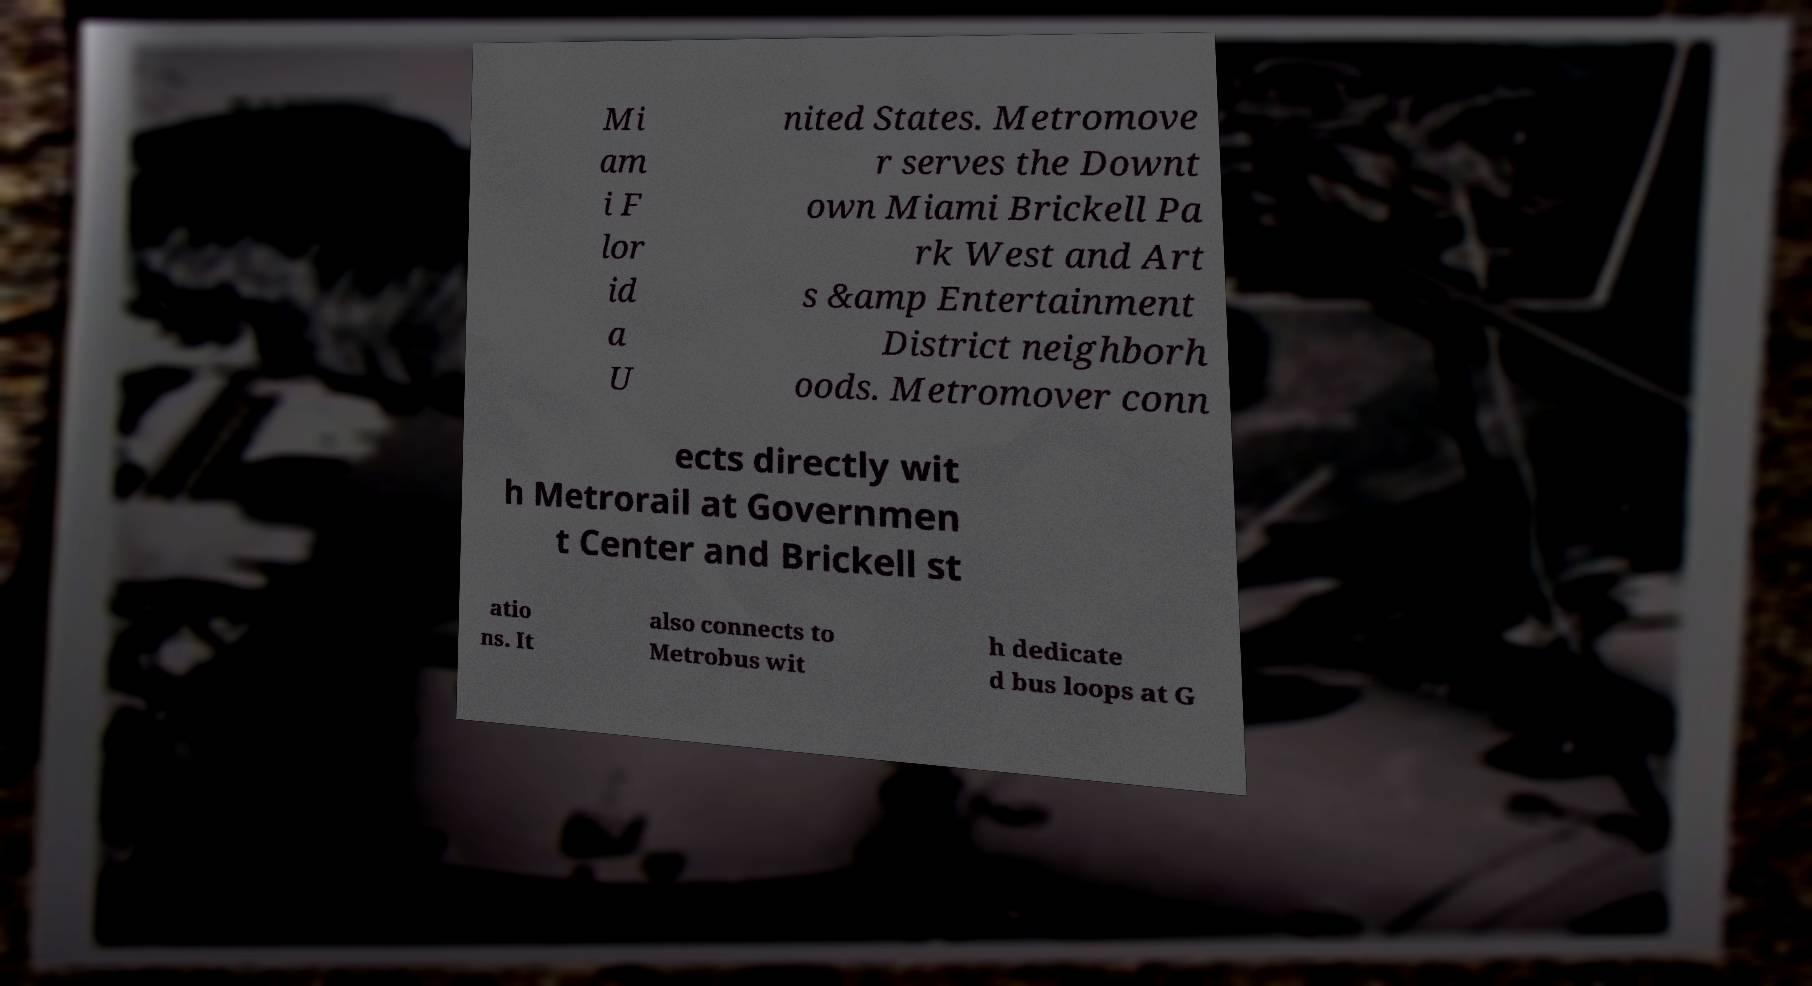Could you assist in decoding the text presented in this image and type it out clearly? Mi am i F lor id a U nited States. Metromove r serves the Downt own Miami Brickell Pa rk West and Art s &amp Entertainment District neighborh oods. Metromover conn ects directly wit h Metrorail at Governmen t Center and Brickell st atio ns. It also connects to Metrobus wit h dedicate d bus loops at G 